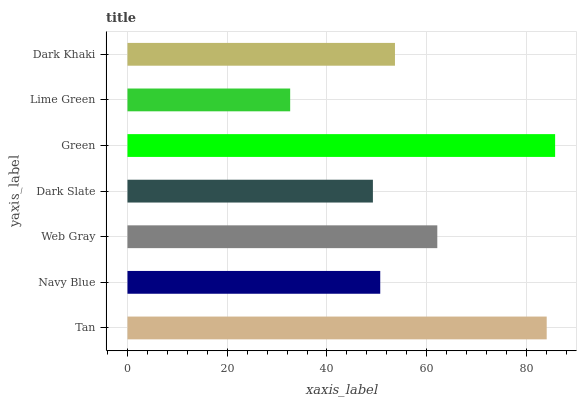Is Lime Green the minimum?
Answer yes or no. Yes. Is Green the maximum?
Answer yes or no. Yes. Is Navy Blue the minimum?
Answer yes or no. No. Is Navy Blue the maximum?
Answer yes or no. No. Is Tan greater than Navy Blue?
Answer yes or no. Yes. Is Navy Blue less than Tan?
Answer yes or no. Yes. Is Navy Blue greater than Tan?
Answer yes or no. No. Is Tan less than Navy Blue?
Answer yes or no. No. Is Dark Khaki the high median?
Answer yes or no. Yes. Is Dark Khaki the low median?
Answer yes or no. Yes. Is Web Gray the high median?
Answer yes or no. No. Is Tan the low median?
Answer yes or no. No. 